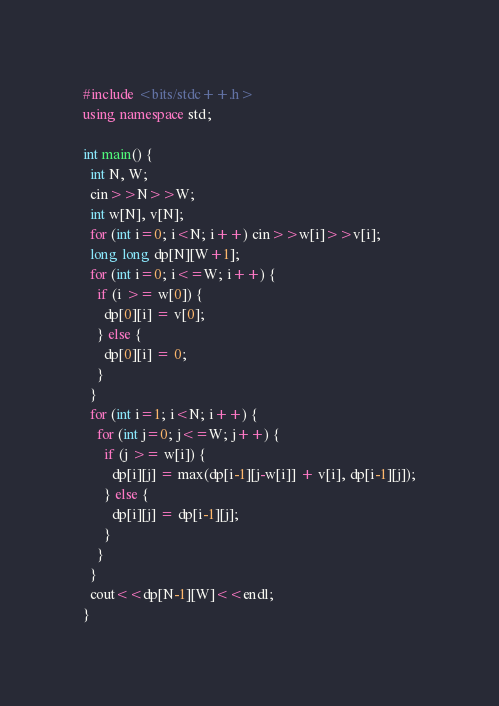Convert code to text. <code><loc_0><loc_0><loc_500><loc_500><_C++_>#include <bits/stdc++.h>
using namespace std;

int main() {
  int N, W;
  cin>>N>>W;
  int w[N], v[N];
  for (int i=0; i<N; i++) cin>>w[i]>>v[i];
  long long dp[N][W+1];
  for (int i=0; i<=W; i++) {
    if (i >= w[0]) {
      dp[0][i] = v[0];
    } else {
      dp[0][i] = 0;
    }
  }
  for (int i=1; i<N; i++) {
    for (int j=0; j<=W; j++) {
      if (j >= w[i]) {
        dp[i][j] = max(dp[i-1][j-w[i]] + v[i], dp[i-1][j]);
      } else {
        dp[i][j] = dp[i-1][j];
      }
    }
  }
  cout<<dp[N-1][W]<<endl;
}</code> 